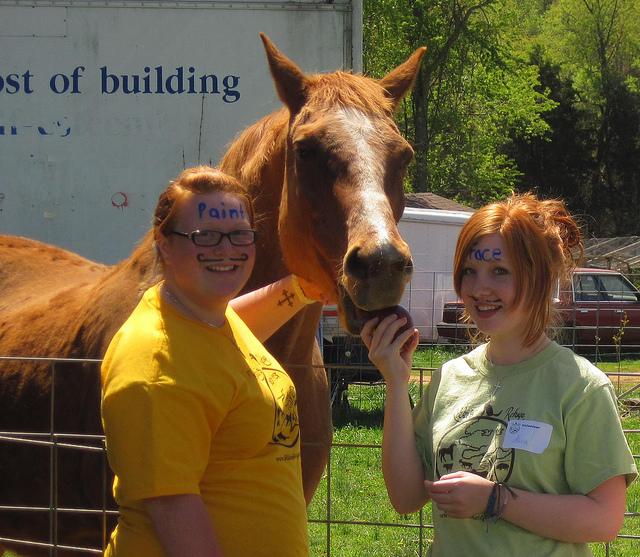What type of tattoo is shown?
Concise answer only. Cross. Is the apple ripe?
Be succinct. Yes. What animal is this?
Answer briefly. Horse. What color are the animal's ears?
Be succinct. Brown. 